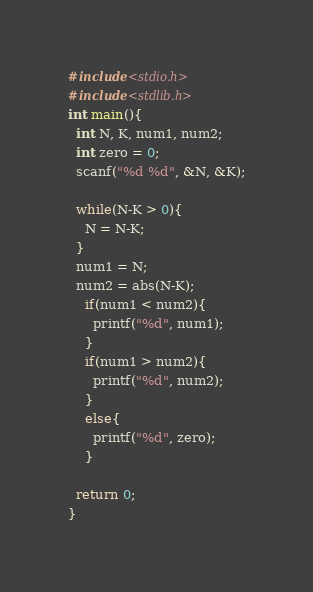Convert code to text. <code><loc_0><loc_0><loc_500><loc_500><_C_>#include<stdio.h>
#include<stdlib.h>
int main(){
  int N, K, num1, num2;
  int zero = 0;
  scanf("%d %d", &N, &K);
  
  while(N-K > 0){
    N = N-K;
  }
  num1 = N;
  num2 = abs(N-K);
	if(num1 < num2){
      printf("%d", num1);
    }
  	if(num1 > num2){
      printf("%d", num2);
    }
  	else{
      printf("%d", zero);
    }
  
  return 0;
}</code> 